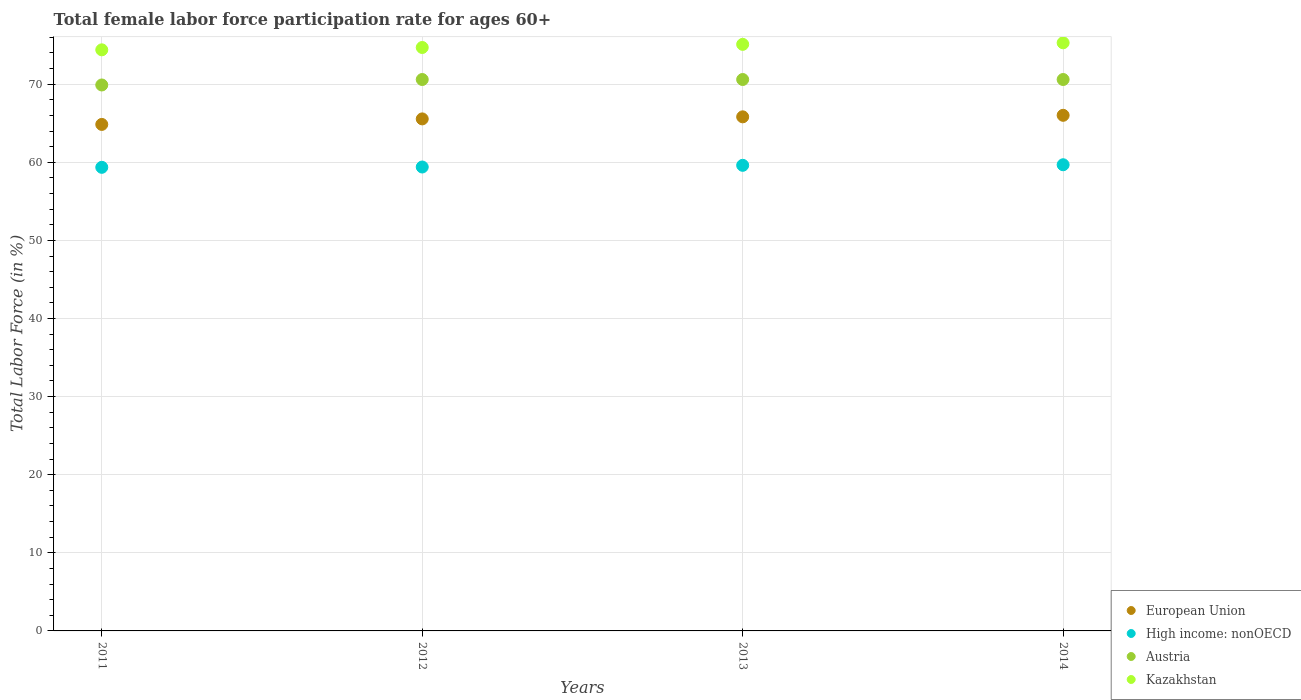How many different coloured dotlines are there?
Offer a terse response. 4. What is the female labor force participation rate in Kazakhstan in 2011?
Your response must be concise. 74.4. Across all years, what is the maximum female labor force participation rate in Kazakhstan?
Your answer should be very brief. 75.3. Across all years, what is the minimum female labor force participation rate in Kazakhstan?
Your answer should be compact. 74.4. In which year was the female labor force participation rate in High income: nonOECD maximum?
Your answer should be compact. 2014. What is the total female labor force participation rate in High income: nonOECD in the graph?
Provide a short and direct response. 238.05. What is the difference between the female labor force participation rate in Kazakhstan in 2011 and that in 2013?
Provide a short and direct response. -0.7. What is the difference between the female labor force participation rate in European Union in 2013 and the female labor force participation rate in Kazakhstan in 2014?
Your answer should be very brief. -9.48. What is the average female labor force participation rate in Austria per year?
Make the answer very short. 70.42. In the year 2013, what is the difference between the female labor force participation rate in High income: nonOECD and female labor force participation rate in Kazakhstan?
Offer a terse response. -15.49. What is the ratio of the female labor force participation rate in High income: nonOECD in 2013 to that in 2014?
Give a very brief answer. 1. Is the female labor force participation rate in European Union in 2012 less than that in 2013?
Your answer should be compact. Yes. Is the difference between the female labor force participation rate in High income: nonOECD in 2012 and 2013 greater than the difference between the female labor force participation rate in Kazakhstan in 2012 and 2013?
Offer a very short reply. Yes. What is the difference between the highest and the second highest female labor force participation rate in European Union?
Your answer should be very brief. 0.2. What is the difference between the highest and the lowest female labor force participation rate in Kazakhstan?
Give a very brief answer. 0.9. In how many years, is the female labor force participation rate in Austria greater than the average female labor force participation rate in Austria taken over all years?
Your response must be concise. 3. Is the sum of the female labor force participation rate in Kazakhstan in 2013 and 2014 greater than the maximum female labor force participation rate in High income: nonOECD across all years?
Provide a succinct answer. Yes. Does the graph contain any zero values?
Your answer should be very brief. No. Where does the legend appear in the graph?
Provide a short and direct response. Bottom right. How many legend labels are there?
Provide a short and direct response. 4. How are the legend labels stacked?
Your answer should be compact. Vertical. What is the title of the graph?
Your answer should be very brief. Total female labor force participation rate for ages 60+. What is the Total Labor Force (in %) of European Union in 2011?
Provide a short and direct response. 64.85. What is the Total Labor Force (in %) in High income: nonOECD in 2011?
Give a very brief answer. 59.36. What is the Total Labor Force (in %) in Austria in 2011?
Ensure brevity in your answer.  69.9. What is the Total Labor Force (in %) in Kazakhstan in 2011?
Make the answer very short. 74.4. What is the Total Labor Force (in %) in European Union in 2012?
Offer a very short reply. 65.56. What is the Total Labor Force (in %) in High income: nonOECD in 2012?
Your response must be concise. 59.4. What is the Total Labor Force (in %) in Austria in 2012?
Provide a succinct answer. 70.6. What is the Total Labor Force (in %) of Kazakhstan in 2012?
Give a very brief answer. 74.7. What is the Total Labor Force (in %) of European Union in 2013?
Keep it short and to the point. 65.82. What is the Total Labor Force (in %) in High income: nonOECD in 2013?
Your answer should be compact. 59.61. What is the Total Labor Force (in %) of Austria in 2013?
Give a very brief answer. 70.6. What is the Total Labor Force (in %) in Kazakhstan in 2013?
Provide a short and direct response. 75.1. What is the Total Labor Force (in %) of European Union in 2014?
Provide a succinct answer. 66.02. What is the Total Labor Force (in %) in High income: nonOECD in 2014?
Provide a short and direct response. 59.69. What is the Total Labor Force (in %) of Austria in 2014?
Your answer should be compact. 70.6. What is the Total Labor Force (in %) of Kazakhstan in 2014?
Your answer should be compact. 75.3. Across all years, what is the maximum Total Labor Force (in %) of European Union?
Provide a short and direct response. 66.02. Across all years, what is the maximum Total Labor Force (in %) of High income: nonOECD?
Make the answer very short. 59.69. Across all years, what is the maximum Total Labor Force (in %) of Austria?
Your answer should be compact. 70.6. Across all years, what is the maximum Total Labor Force (in %) of Kazakhstan?
Make the answer very short. 75.3. Across all years, what is the minimum Total Labor Force (in %) of European Union?
Your answer should be compact. 64.85. Across all years, what is the minimum Total Labor Force (in %) of High income: nonOECD?
Provide a short and direct response. 59.36. Across all years, what is the minimum Total Labor Force (in %) in Austria?
Offer a very short reply. 69.9. Across all years, what is the minimum Total Labor Force (in %) in Kazakhstan?
Offer a very short reply. 74.4. What is the total Total Labor Force (in %) of European Union in the graph?
Offer a very short reply. 262.24. What is the total Total Labor Force (in %) in High income: nonOECD in the graph?
Your answer should be very brief. 238.05. What is the total Total Labor Force (in %) in Austria in the graph?
Offer a very short reply. 281.7. What is the total Total Labor Force (in %) of Kazakhstan in the graph?
Ensure brevity in your answer.  299.5. What is the difference between the Total Labor Force (in %) of European Union in 2011 and that in 2012?
Make the answer very short. -0.71. What is the difference between the Total Labor Force (in %) of High income: nonOECD in 2011 and that in 2012?
Your answer should be very brief. -0.04. What is the difference between the Total Labor Force (in %) of Austria in 2011 and that in 2012?
Provide a succinct answer. -0.7. What is the difference between the Total Labor Force (in %) of Kazakhstan in 2011 and that in 2012?
Your answer should be compact. -0.3. What is the difference between the Total Labor Force (in %) of European Union in 2011 and that in 2013?
Your answer should be compact. -0.97. What is the difference between the Total Labor Force (in %) of High income: nonOECD in 2011 and that in 2013?
Your answer should be compact. -0.26. What is the difference between the Total Labor Force (in %) of Austria in 2011 and that in 2013?
Offer a very short reply. -0.7. What is the difference between the Total Labor Force (in %) in European Union in 2011 and that in 2014?
Offer a very short reply. -1.17. What is the difference between the Total Labor Force (in %) in High income: nonOECD in 2011 and that in 2014?
Your response must be concise. -0.33. What is the difference between the Total Labor Force (in %) in Austria in 2011 and that in 2014?
Ensure brevity in your answer.  -0.7. What is the difference between the Total Labor Force (in %) in European Union in 2012 and that in 2013?
Make the answer very short. -0.26. What is the difference between the Total Labor Force (in %) of High income: nonOECD in 2012 and that in 2013?
Keep it short and to the point. -0.22. What is the difference between the Total Labor Force (in %) of Kazakhstan in 2012 and that in 2013?
Your response must be concise. -0.4. What is the difference between the Total Labor Force (in %) in European Union in 2012 and that in 2014?
Your answer should be compact. -0.46. What is the difference between the Total Labor Force (in %) in High income: nonOECD in 2012 and that in 2014?
Make the answer very short. -0.29. What is the difference between the Total Labor Force (in %) in Kazakhstan in 2012 and that in 2014?
Your answer should be compact. -0.6. What is the difference between the Total Labor Force (in %) in European Union in 2013 and that in 2014?
Give a very brief answer. -0.2. What is the difference between the Total Labor Force (in %) of High income: nonOECD in 2013 and that in 2014?
Your answer should be compact. -0.07. What is the difference between the Total Labor Force (in %) in Kazakhstan in 2013 and that in 2014?
Provide a succinct answer. -0.2. What is the difference between the Total Labor Force (in %) of European Union in 2011 and the Total Labor Force (in %) of High income: nonOECD in 2012?
Provide a succinct answer. 5.45. What is the difference between the Total Labor Force (in %) in European Union in 2011 and the Total Labor Force (in %) in Austria in 2012?
Provide a short and direct response. -5.75. What is the difference between the Total Labor Force (in %) in European Union in 2011 and the Total Labor Force (in %) in Kazakhstan in 2012?
Offer a very short reply. -9.85. What is the difference between the Total Labor Force (in %) of High income: nonOECD in 2011 and the Total Labor Force (in %) of Austria in 2012?
Your answer should be very brief. -11.24. What is the difference between the Total Labor Force (in %) in High income: nonOECD in 2011 and the Total Labor Force (in %) in Kazakhstan in 2012?
Ensure brevity in your answer.  -15.34. What is the difference between the Total Labor Force (in %) in European Union in 2011 and the Total Labor Force (in %) in High income: nonOECD in 2013?
Provide a short and direct response. 5.24. What is the difference between the Total Labor Force (in %) of European Union in 2011 and the Total Labor Force (in %) of Austria in 2013?
Provide a short and direct response. -5.75. What is the difference between the Total Labor Force (in %) of European Union in 2011 and the Total Labor Force (in %) of Kazakhstan in 2013?
Keep it short and to the point. -10.25. What is the difference between the Total Labor Force (in %) of High income: nonOECD in 2011 and the Total Labor Force (in %) of Austria in 2013?
Your response must be concise. -11.24. What is the difference between the Total Labor Force (in %) of High income: nonOECD in 2011 and the Total Labor Force (in %) of Kazakhstan in 2013?
Offer a terse response. -15.74. What is the difference between the Total Labor Force (in %) in Austria in 2011 and the Total Labor Force (in %) in Kazakhstan in 2013?
Your response must be concise. -5.2. What is the difference between the Total Labor Force (in %) in European Union in 2011 and the Total Labor Force (in %) in High income: nonOECD in 2014?
Provide a succinct answer. 5.16. What is the difference between the Total Labor Force (in %) of European Union in 2011 and the Total Labor Force (in %) of Austria in 2014?
Ensure brevity in your answer.  -5.75. What is the difference between the Total Labor Force (in %) in European Union in 2011 and the Total Labor Force (in %) in Kazakhstan in 2014?
Keep it short and to the point. -10.45. What is the difference between the Total Labor Force (in %) in High income: nonOECD in 2011 and the Total Labor Force (in %) in Austria in 2014?
Your answer should be compact. -11.24. What is the difference between the Total Labor Force (in %) in High income: nonOECD in 2011 and the Total Labor Force (in %) in Kazakhstan in 2014?
Ensure brevity in your answer.  -15.94. What is the difference between the Total Labor Force (in %) in Austria in 2011 and the Total Labor Force (in %) in Kazakhstan in 2014?
Offer a terse response. -5.4. What is the difference between the Total Labor Force (in %) of European Union in 2012 and the Total Labor Force (in %) of High income: nonOECD in 2013?
Keep it short and to the point. 5.94. What is the difference between the Total Labor Force (in %) of European Union in 2012 and the Total Labor Force (in %) of Austria in 2013?
Your response must be concise. -5.04. What is the difference between the Total Labor Force (in %) in European Union in 2012 and the Total Labor Force (in %) in Kazakhstan in 2013?
Your answer should be compact. -9.54. What is the difference between the Total Labor Force (in %) in High income: nonOECD in 2012 and the Total Labor Force (in %) in Austria in 2013?
Give a very brief answer. -11.2. What is the difference between the Total Labor Force (in %) in High income: nonOECD in 2012 and the Total Labor Force (in %) in Kazakhstan in 2013?
Provide a short and direct response. -15.7. What is the difference between the Total Labor Force (in %) in Austria in 2012 and the Total Labor Force (in %) in Kazakhstan in 2013?
Offer a very short reply. -4.5. What is the difference between the Total Labor Force (in %) in European Union in 2012 and the Total Labor Force (in %) in High income: nonOECD in 2014?
Ensure brevity in your answer.  5.87. What is the difference between the Total Labor Force (in %) in European Union in 2012 and the Total Labor Force (in %) in Austria in 2014?
Your answer should be compact. -5.04. What is the difference between the Total Labor Force (in %) in European Union in 2012 and the Total Labor Force (in %) in Kazakhstan in 2014?
Provide a short and direct response. -9.74. What is the difference between the Total Labor Force (in %) in High income: nonOECD in 2012 and the Total Labor Force (in %) in Austria in 2014?
Offer a terse response. -11.2. What is the difference between the Total Labor Force (in %) in High income: nonOECD in 2012 and the Total Labor Force (in %) in Kazakhstan in 2014?
Make the answer very short. -15.9. What is the difference between the Total Labor Force (in %) of Austria in 2012 and the Total Labor Force (in %) of Kazakhstan in 2014?
Your answer should be very brief. -4.7. What is the difference between the Total Labor Force (in %) of European Union in 2013 and the Total Labor Force (in %) of High income: nonOECD in 2014?
Make the answer very short. 6.13. What is the difference between the Total Labor Force (in %) of European Union in 2013 and the Total Labor Force (in %) of Austria in 2014?
Provide a succinct answer. -4.78. What is the difference between the Total Labor Force (in %) in European Union in 2013 and the Total Labor Force (in %) in Kazakhstan in 2014?
Give a very brief answer. -9.48. What is the difference between the Total Labor Force (in %) of High income: nonOECD in 2013 and the Total Labor Force (in %) of Austria in 2014?
Your response must be concise. -10.99. What is the difference between the Total Labor Force (in %) in High income: nonOECD in 2013 and the Total Labor Force (in %) in Kazakhstan in 2014?
Provide a short and direct response. -15.69. What is the difference between the Total Labor Force (in %) in Austria in 2013 and the Total Labor Force (in %) in Kazakhstan in 2014?
Provide a short and direct response. -4.7. What is the average Total Labor Force (in %) in European Union per year?
Ensure brevity in your answer.  65.56. What is the average Total Labor Force (in %) in High income: nonOECD per year?
Your response must be concise. 59.51. What is the average Total Labor Force (in %) in Austria per year?
Your response must be concise. 70.42. What is the average Total Labor Force (in %) of Kazakhstan per year?
Make the answer very short. 74.88. In the year 2011, what is the difference between the Total Labor Force (in %) of European Union and Total Labor Force (in %) of High income: nonOECD?
Ensure brevity in your answer.  5.49. In the year 2011, what is the difference between the Total Labor Force (in %) of European Union and Total Labor Force (in %) of Austria?
Your answer should be very brief. -5.05. In the year 2011, what is the difference between the Total Labor Force (in %) of European Union and Total Labor Force (in %) of Kazakhstan?
Ensure brevity in your answer.  -9.55. In the year 2011, what is the difference between the Total Labor Force (in %) in High income: nonOECD and Total Labor Force (in %) in Austria?
Make the answer very short. -10.54. In the year 2011, what is the difference between the Total Labor Force (in %) in High income: nonOECD and Total Labor Force (in %) in Kazakhstan?
Your answer should be compact. -15.04. In the year 2011, what is the difference between the Total Labor Force (in %) of Austria and Total Labor Force (in %) of Kazakhstan?
Keep it short and to the point. -4.5. In the year 2012, what is the difference between the Total Labor Force (in %) in European Union and Total Labor Force (in %) in High income: nonOECD?
Make the answer very short. 6.16. In the year 2012, what is the difference between the Total Labor Force (in %) of European Union and Total Labor Force (in %) of Austria?
Give a very brief answer. -5.04. In the year 2012, what is the difference between the Total Labor Force (in %) of European Union and Total Labor Force (in %) of Kazakhstan?
Make the answer very short. -9.14. In the year 2012, what is the difference between the Total Labor Force (in %) of High income: nonOECD and Total Labor Force (in %) of Austria?
Provide a succinct answer. -11.2. In the year 2012, what is the difference between the Total Labor Force (in %) in High income: nonOECD and Total Labor Force (in %) in Kazakhstan?
Provide a short and direct response. -15.3. In the year 2012, what is the difference between the Total Labor Force (in %) in Austria and Total Labor Force (in %) in Kazakhstan?
Your answer should be compact. -4.1. In the year 2013, what is the difference between the Total Labor Force (in %) in European Union and Total Labor Force (in %) in High income: nonOECD?
Your answer should be compact. 6.21. In the year 2013, what is the difference between the Total Labor Force (in %) in European Union and Total Labor Force (in %) in Austria?
Ensure brevity in your answer.  -4.78. In the year 2013, what is the difference between the Total Labor Force (in %) of European Union and Total Labor Force (in %) of Kazakhstan?
Provide a short and direct response. -9.28. In the year 2013, what is the difference between the Total Labor Force (in %) in High income: nonOECD and Total Labor Force (in %) in Austria?
Ensure brevity in your answer.  -10.99. In the year 2013, what is the difference between the Total Labor Force (in %) in High income: nonOECD and Total Labor Force (in %) in Kazakhstan?
Give a very brief answer. -15.49. In the year 2013, what is the difference between the Total Labor Force (in %) of Austria and Total Labor Force (in %) of Kazakhstan?
Offer a terse response. -4.5. In the year 2014, what is the difference between the Total Labor Force (in %) of European Union and Total Labor Force (in %) of High income: nonOECD?
Ensure brevity in your answer.  6.33. In the year 2014, what is the difference between the Total Labor Force (in %) in European Union and Total Labor Force (in %) in Austria?
Your answer should be compact. -4.58. In the year 2014, what is the difference between the Total Labor Force (in %) in European Union and Total Labor Force (in %) in Kazakhstan?
Your response must be concise. -9.28. In the year 2014, what is the difference between the Total Labor Force (in %) of High income: nonOECD and Total Labor Force (in %) of Austria?
Ensure brevity in your answer.  -10.91. In the year 2014, what is the difference between the Total Labor Force (in %) in High income: nonOECD and Total Labor Force (in %) in Kazakhstan?
Make the answer very short. -15.61. What is the ratio of the Total Labor Force (in %) of High income: nonOECD in 2011 to that in 2012?
Provide a short and direct response. 1. What is the ratio of the Total Labor Force (in %) in Austria in 2011 to that in 2012?
Give a very brief answer. 0.99. What is the ratio of the Total Labor Force (in %) in European Union in 2011 to that in 2013?
Offer a very short reply. 0.99. What is the ratio of the Total Labor Force (in %) of Austria in 2011 to that in 2013?
Make the answer very short. 0.99. What is the ratio of the Total Labor Force (in %) of Kazakhstan in 2011 to that in 2013?
Give a very brief answer. 0.99. What is the ratio of the Total Labor Force (in %) of European Union in 2011 to that in 2014?
Keep it short and to the point. 0.98. What is the ratio of the Total Labor Force (in %) of High income: nonOECD in 2011 to that in 2014?
Provide a succinct answer. 0.99. What is the ratio of the Total Labor Force (in %) in Kazakhstan in 2011 to that in 2014?
Provide a short and direct response. 0.99. What is the ratio of the Total Labor Force (in %) of High income: nonOECD in 2012 to that in 2013?
Your answer should be compact. 1. What is the ratio of the Total Labor Force (in %) of European Union in 2012 to that in 2014?
Your response must be concise. 0.99. What is the ratio of the Total Labor Force (in %) of High income: nonOECD in 2012 to that in 2014?
Ensure brevity in your answer.  1. What is the ratio of the Total Labor Force (in %) of Kazakhstan in 2012 to that in 2014?
Keep it short and to the point. 0.99. What is the ratio of the Total Labor Force (in %) of European Union in 2013 to that in 2014?
Your response must be concise. 1. What is the ratio of the Total Labor Force (in %) in High income: nonOECD in 2013 to that in 2014?
Your answer should be very brief. 1. What is the ratio of the Total Labor Force (in %) in Kazakhstan in 2013 to that in 2014?
Keep it short and to the point. 1. What is the difference between the highest and the second highest Total Labor Force (in %) of European Union?
Keep it short and to the point. 0.2. What is the difference between the highest and the second highest Total Labor Force (in %) of High income: nonOECD?
Make the answer very short. 0.07. What is the difference between the highest and the second highest Total Labor Force (in %) of Austria?
Your answer should be very brief. 0. What is the difference between the highest and the lowest Total Labor Force (in %) in European Union?
Keep it short and to the point. 1.17. What is the difference between the highest and the lowest Total Labor Force (in %) in High income: nonOECD?
Ensure brevity in your answer.  0.33. What is the difference between the highest and the lowest Total Labor Force (in %) of Austria?
Provide a short and direct response. 0.7. 